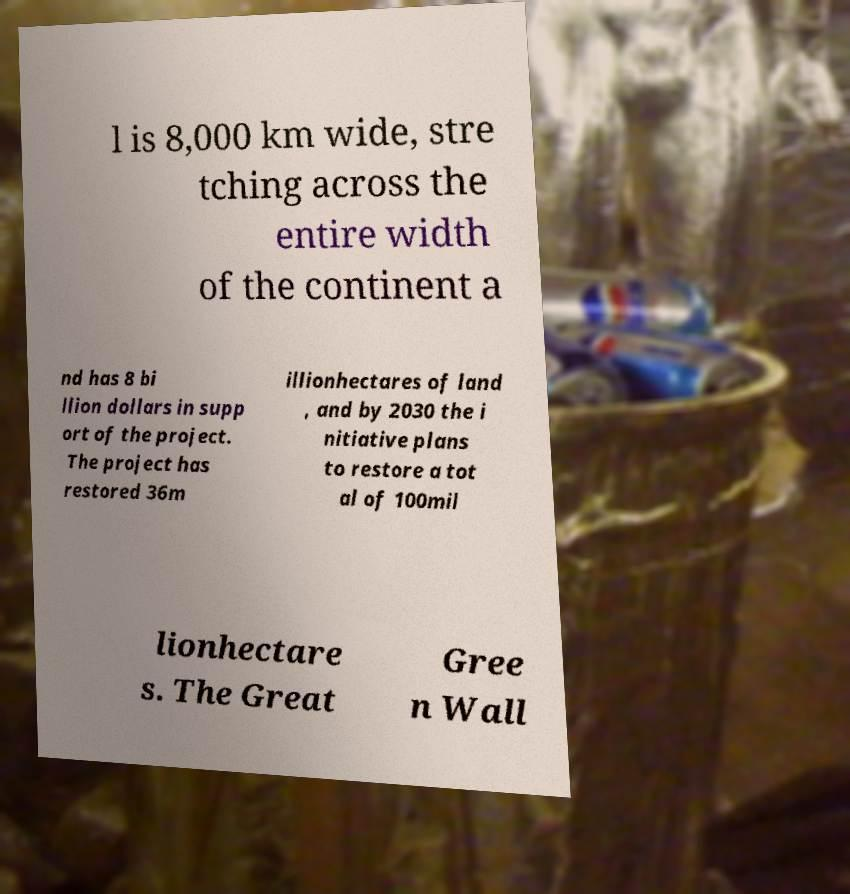Can you accurately transcribe the text from the provided image for me? l is 8,000 km wide, stre tching across the entire width of the continent a nd has 8 bi llion dollars in supp ort of the project. The project has restored 36m illionhectares of land , and by 2030 the i nitiative plans to restore a tot al of 100mil lionhectare s. The Great Gree n Wall 